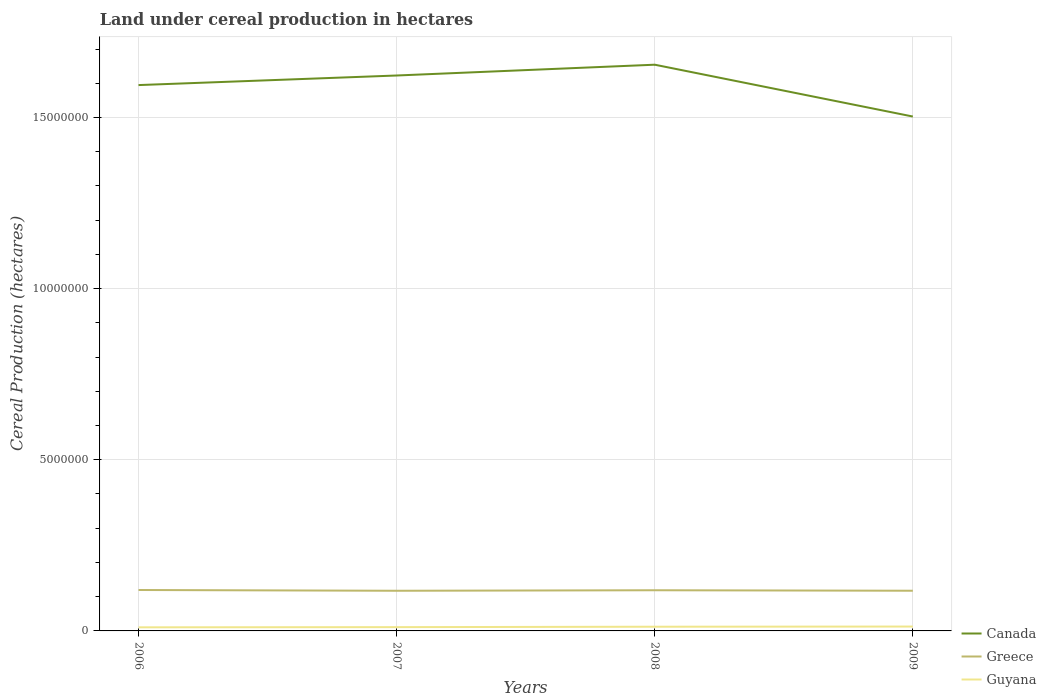How many different coloured lines are there?
Offer a very short reply. 3. Is the number of lines equal to the number of legend labels?
Your response must be concise. Yes. Across all years, what is the maximum land under cereal production in Canada?
Your response must be concise. 1.50e+07. What is the total land under cereal production in Greece in the graph?
Your answer should be compact. 7360. What is the difference between the highest and the second highest land under cereal production in Canada?
Offer a terse response. 1.51e+06. What is the difference between two consecutive major ticks on the Y-axis?
Ensure brevity in your answer.  5.00e+06. Are the values on the major ticks of Y-axis written in scientific E-notation?
Your response must be concise. No. Does the graph contain grids?
Your response must be concise. Yes. Where does the legend appear in the graph?
Your answer should be very brief. Bottom right. What is the title of the graph?
Keep it short and to the point. Land under cereal production in hectares. What is the label or title of the Y-axis?
Your answer should be compact. Cereal Production (hectares). What is the Cereal Production (hectares) in Canada in 2006?
Your answer should be compact. 1.59e+07. What is the Cereal Production (hectares) in Greece in 2006?
Give a very brief answer. 1.20e+06. What is the Cereal Production (hectares) of Guyana in 2006?
Your answer should be very brief. 1.05e+05. What is the Cereal Production (hectares) in Canada in 2007?
Your answer should be compact. 1.62e+07. What is the Cereal Production (hectares) of Greece in 2007?
Provide a succinct answer. 1.17e+06. What is the Cereal Production (hectares) of Guyana in 2007?
Offer a very short reply. 1.10e+05. What is the Cereal Production (hectares) in Canada in 2008?
Your answer should be compact. 1.65e+07. What is the Cereal Production (hectares) of Greece in 2008?
Keep it short and to the point. 1.19e+06. What is the Cereal Production (hectares) of Guyana in 2008?
Ensure brevity in your answer.  1.23e+05. What is the Cereal Production (hectares) of Canada in 2009?
Make the answer very short. 1.50e+07. What is the Cereal Production (hectares) in Greece in 2009?
Offer a very short reply. 1.17e+06. What is the Cereal Production (hectares) in Guyana in 2009?
Provide a succinct answer. 1.28e+05. Across all years, what is the maximum Cereal Production (hectares) of Canada?
Keep it short and to the point. 1.65e+07. Across all years, what is the maximum Cereal Production (hectares) in Greece?
Offer a very short reply. 1.20e+06. Across all years, what is the maximum Cereal Production (hectares) in Guyana?
Ensure brevity in your answer.  1.28e+05. Across all years, what is the minimum Cereal Production (hectares) of Canada?
Keep it short and to the point. 1.50e+07. Across all years, what is the minimum Cereal Production (hectares) in Greece?
Your answer should be compact. 1.17e+06. Across all years, what is the minimum Cereal Production (hectares) of Guyana?
Your answer should be compact. 1.05e+05. What is the total Cereal Production (hectares) of Canada in the graph?
Your answer should be compact. 6.37e+07. What is the total Cereal Production (hectares) of Greece in the graph?
Offer a terse response. 4.73e+06. What is the total Cereal Production (hectares) in Guyana in the graph?
Your answer should be compact. 4.66e+05. What is the difference between the Cereal Production (hectares) in Canada in 2006 and that in 2007?
Your answer should be very brief. -2.80e+05. What is the difference between the Cereal Production (hectares) of Greece in 2006 and that in 2007?
Give a very brief answer. 2.26e+04. What is the difference between the Cereal Production (hectares) of Guyana in 2006 and that in 2007?
Provide a short and direct response. -5400. What is the difference between the Cereal Production (hectares) of Canada in 2006 and that in 2008?
Offer a terse response. -5.95e+05. What is the difference between the Cereal Production (hectares) of Greece in 2006 and that in 2008?
Give a very brief answer. 7360. What is the difference between the Cereal Production (hectares) of Guyana in 2006 and that in 2008?
Your answer should be very brief. -1.77e+04. What is the difference between the Cereal Production (hectares) in Canada in 2006 and that in 2009?
Provide a succinct answer. 9.19e+05. What is the difference between the Cereal Production (hectares) of Greece in 2006 and that in 2009?
Your answer should be compact. 2.18e+04. What is the difference between the Cereal Production (hectares) in Guyana in 2006 and that in 2009?
Provide a succinct answer. -2.28e+04. What is the difference between the Cereal Production (hectares) of Canada in 2007 and that in 2008?
Keep it short and to the point. -3.15e+05. What is the difference between the Cereal Production (hectares) of Greece in 2007 and that in 2008?
Keep it short and to the point. -1.53e+04. What is the difference between the Cereal Production (hectares) in Guyana in 2007 and that in 2008?
Make the answer very short. -1.23e+04. What is the difference between the Cereal Production (hectares) of Canada in 2007 and that in 2009?
Make the answer very short. 1.20e+06. What is the difference between the Cereal Production (hectares) of Greece in 2007 and that in 2009?
Make the answer very short. -851. What is the difference between the Cereal Production (hectares) in Guyana in 2007 and that in 2009?
Keep it short and to the point. -1.74e+04. What is the difference between the Cereal Production (hectares) of Canada in 2008 and that in 2009?
Offer a very short reply. 1.51e+06. What is the difference between the Cereal Production (hectares) of Greece in 2008 and that in 2009?
Your response must be concise. 1.44e+04. What is the difference between the Cereal Production (hectares) of Guyana in 2008 and that in 2009?
Keep it short and to the point. -5125. What is the difference between the Cereal Production (hectares) of Canada in 2006 and the Cereal Production (hectares) of Greece in 2007?
Your response must be concise. 1.48e+07. What is the difference between the Cereal Production (hectares) of Canada in 2006 and the Cereal Production (hectares) of Guyana in 2007?
Offer a terse response. 1.58e+07. What is the difference between the Cereal Production (hectares) in Greece in 2006 and the Cereal Production (hectares) in Guyana in 2007?
Your response must be concise. 1.09e+06. What is the difference between the Cereal Production (hectares) in Canada in 2006 and the Cereal Production (hectares) in Greece in 2008?
Keep it short and to the point. 1.48e+07. What is the difference between the Cereal Production (hectares) in Canada in 2006 and the Cereal Production (hectares) in Guyana in 2008?
Your answer should be very brief. 1.58e+07. What is the difference between the Cereal Production (hectares) of Greece in 2006 and the Cereal Production (hectares) of Guyana in 2008?
Make the answer very short. 1.07e+06. What is the difference between the Cereal Production (hectares) of Canada in 2006 and the Cereal Production (hectares) of Greece in 2009?
Offer a very short reply. 1.48e+07. What is the difference between the Cereal Production (hectares) of Canada in 2006 and the Cereal Production (hectares) of Guyana in 2009?
Provide a short and direct response. 1.58e+07. What is the difference between the Cereal Production (hectares) in Greece in 2006 and the Cereal Production (hectares) in Guyana in 2009?
Make the answer very short. 1.07e+06. What is the difference between the Cereal Production (hectares) in Canada in 2007 and the Cereal Production (hectares) in Greece in 2008?
Make the answer very short. 1.50e+07. What is the difference between the Cereal Production (hectares) of Canada in 2007 and the Cereal Production (hectares) of Guyana in 2008?
Your answer should be very brief. 1.61e+07. What is the difference between the Cereal Production (hectares) of Greece in 2007 and the Cereal Production (hectares) of Guyana in 2008?
Keep it short and to the point. 1.05e+06. What is the difference between the Cereal Production (hectares) in Canada in 2007 and the Cereal Production (hectares) in Greece in 2009?
Ensure brevity in your answer.  1.51e+07. What is the difference between the Cereal Production (hectares) in Canada in 2007 and the Cereal Production (hectares) in Guyana in 2009?
Your answer should be compact. 1.61e+07. What is the difference between the Cereal Production (hectares) in Greece in 2007 and the Cereal Production (hectares) in Guyana in 2009?
Your response must be concise. 1.05e+06. What is the difference between the Cereal Production (hectares) of Canada in 2008 and the Cereal Production (hectares) of Greece in 2009?
Your answer should be very brief. 1.54e+07. What is the difference between the Cereal Production (hectares) in Canada in 2008 and the Cereal Production (hectares) in Guyana in 2009?
Provide a succinct answer. 1.64e+07. What is the difference between the Cereal Production (hectares) of Greece in 2008 and the Cereal Production (hectares) of Guyana in 2009?
Provide a succinct answer. 1.06e+06. What is the average Cereal Production (hectares) of Canada per year?
Offer a terse response. 1.59e+07. What is the average Cereal Production (hectares) of Greece per year?
Offer a very short reply. 1.18e+06. What is the average Cereal Production (hectares) of Guyana per year?
Provide a short and direct response. 1.17e+05. In the year 2006, what is the difference between the Cereal Production (hectares) of Canada and Cereal Production (hectares) of Greece?
Your response must be concise. 1.48e+07. In the year 2006, what is the difference between the Cereal Production (hectares) in Canada and Cereal Production (hectares) in Guyana?
Provide a short and direct response. 1.58e+07. In the year 2006, what is the difference between the Cereal Production (hectares) of Greece and Cereal Production (hectares) of Guyana?
Give a very brief answer. 1.09e+06. In the year 2007, what is the difference between the Cereal Production (hectares) in Canada and Cereal Production (hectares) in Greece?
Your answer should be compact. 1.51e+07. In the year 2007, what is the difference between the Cereal Production (hectares) of Canada and Cereal Production (hectares) of Guyana?
Keep it short and to the point. 1.61e+07. In the year 2007, what is the difference between the Cereal Production (hectares) in Greece and Cereal Production (hectares) in Guyana?
Offer a terse response. 1.06e+06. In the year 2008, what is the difference between the Cereal Production (hectares) of Canada and Cereal Production (hectares) of Greece?
Offer a terse response. 1.54e+07. In the year 2008, what is the difference between the Cereal Production (hectares) of Canada and Cereal Production (hectares) of Guyana?
Provide a succinct answer. 1.64e+07. In the year 2008, what is the difference between the Cereal Production (hectares) in Greece and Cereal Production (hectares) in Guyana?
Provide a succinct answer. 1.07e+06. In the year 2009, what is the difference between the Cereal Production (hectares) in Canada and Cereal Production (hectares) in Greece?
Offer a very short reply. 1.39e+07. In the year 2009, what is the difference between the Cereal Production (hectares) in Canada and Cereal Production (hectares) in Guyana?
Your response must be concise. 1.49e+07. In the year 2009, what is the difference between the Cereal Production (hectares) in Greece and Cereal Production (hectares) in Guyana?
Keep it short and to the point. 1.05e+06. What is the ratio of the Cereal Production (hectares) in Canada in 2006 to that in 2007?
Offer a very short reply. 0.98. What is the ratio of the Cereal Production (hectares) in Greece in 2006 to that in 2007?
Keep it short and to the point. 1.02. What is the ratio of the Cereal Production (hectares) of Guyana in 2006 to that in 2007?
Keep it short and to the point. 0.95. What is the ratio of the Cereal Production (hectares) in Greece in 2006 to that in 2008?
Ensure brevity in your answer.  1.01. What is the ratio of the Cereal Production (hectares) in Guyana in 2006 to that in 2008?
Provide a short and direct response. 0.86. What is the ratio of the Cereal Production (hectares) in Canada in 2006 to that in 2009?
Your response must be concise. 1.06. What is the ratio of the Cereal Production (hectares) in Greece in 2006 to that in 2009?
Offer a very short reply. 1.02. What is the ratio of the Cereal Production (hectares) of Guyana in 2006 to that in 2009?
Offer a terse response. 0.82. What is the ratio of the Cereal Production (hectares) in Canada in 2007 to that in 2008?
Give a very brief answer. 0.98. What is the ratio of the Cereal Production (hectares) of Greece in 2007 to that in 2008?
Make the answer very short. 0.99. What is the ratio of the Cereal Production (hectares) in Guyana in 2007 to that in 2008?
Ensure brevity in your answer.  0.9. What is the ratio of the Cereal Production (hectares) of Canada in 2007 to that in 2009?
Offer a terse response. 1.08. What is the ratio of the Cereal Production (hectares) in Greece in 2007 to that in 2009?
Offer a very short reply. 1. What is the ratio of the Cereal Production (hectares) of Guyana in 2007 to that in 2009?
Offer a terse response. 0.86. What is the ratio of the Cereal Production (hectares) in Canada in 2008 to that in 2009?
Your answer should be very brief. 1.1. What is the ratio of the Cereal Production (hectares) in Greece in 2008 to that in 2009?
Offer a very short reply. 1.01. What is the ratio of the Cereal Production (hectares) of Guyana in 2008 to that in 2009?
Ensure brevity in your answer.  0.96. What is the difference between the highest and the second highest Cereal Production (hectares) in Canada?
Your answer should be compact. 3.15e+05. What is the difference between the highest and the second highest Cereal Production (hectares) of Greece?
Provide a short and direct response. 7360. What is the difference between the highest and the second highest Cereal Production (hectares) of Guyana?
Give a very brief answer. 5125. What is the difference between the highest and the lowest Cereal Production (hectares) of Canada?
Provide a succinct answer. 1.51e+06. What is the difference between the highest and the lowest Cereal Production (hectares) of Greece?
Your answer should be very brief. 2.26e+04. What is the difference between the highest and the lowest Cereal Production (hectares) of Guyana?
Keep it short and to the point. 2.28e+04. 